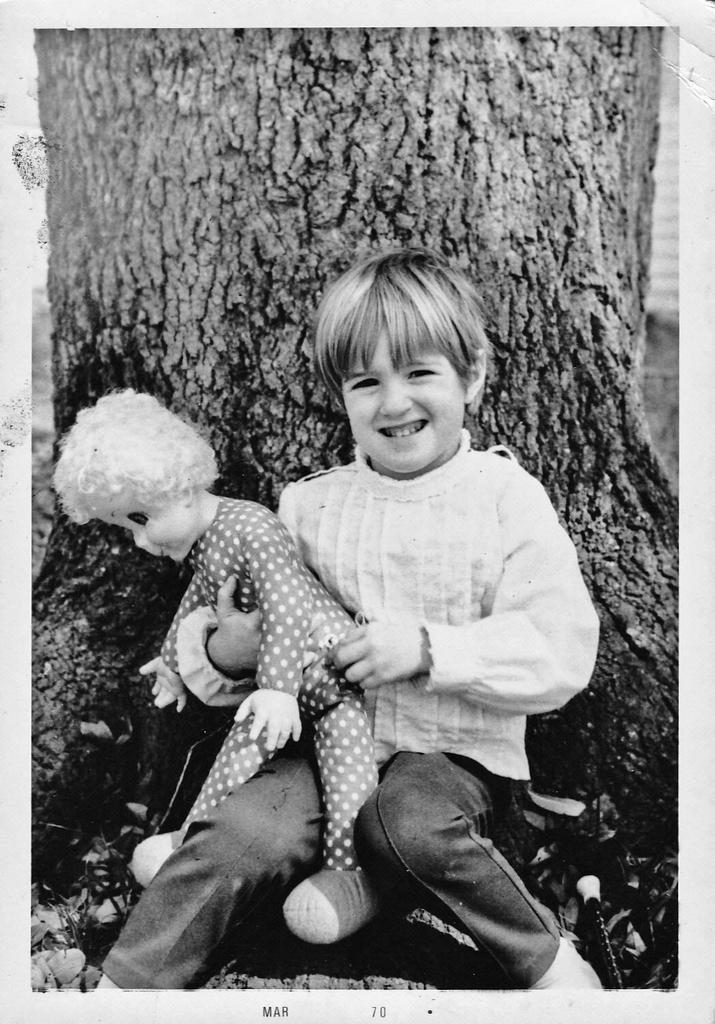What is the color scheme of the image? The image is black and white. What is the boy in the image doing? The boy is sitting in the image. What is the boy holding in the image? The boy is holding a toy. What can be seen in the background of the image? There is a tree trunk in the background of the image. What type of vegetable is the boy eating in the image? There is no vegetable present in the image, and the boy is not eating anything. How many trees are visible in the image? There is only one tree trunk visible in the image, not an entire tree. 